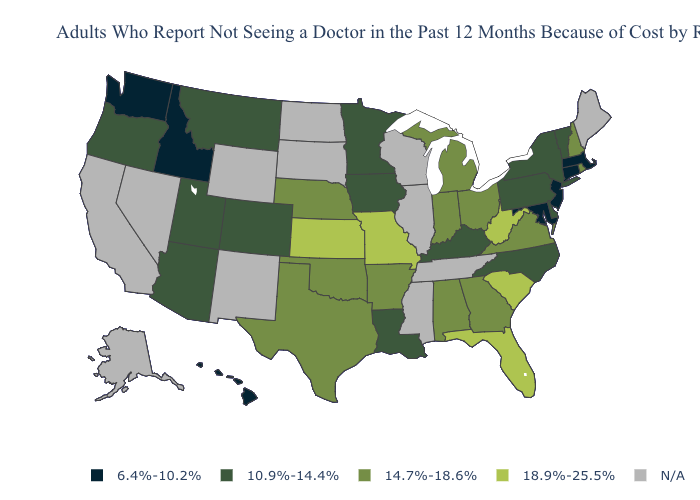Name the states that have a value in the range 18.9%-25.5%?
Short answer required. Florida, Kansas, Missouri, South Carolina, West Virginia. Does the map have missing data?
Be succinct. Yes. Does Maryland have the lowest value in the USA?
Be succinct. Yes. What is the value of Wyoming?
Short answer required. N/A. What is the value of Minnesota?
Short answer required. 10.9%-14.4%. What is the value of Rhode Island?
Write a very short answer. 14.7%-18.6%. Name the states that have a value in the range 18.9%-25.5%?
Concise answer only. Florida, Kansas, Missouri, South Carolina, West Virginia. What is the value of Idaho?
Concise answer only. 6.4%-10.2%. What is the value of Washington?
Short answer required. 6.4%-10.2%. Name the states that have a value in the range 6.4%-10.2%?
Short answer required. Connecticut, Hawaii, Idaho, Maryland, Massachusetts, New Jersey, Washington. Among the states that border Louisiana , which have the highest value?
Answer briefly. Arkansas, Texas. Does Washington have the highest value in the West?
Short answer required. No. What is the highest value in states that border South Carolina?
Quick response, please. 14.7%-18.6%. Among the states that border Illinois , which have the highest value?
Short answer required. Missouri. 